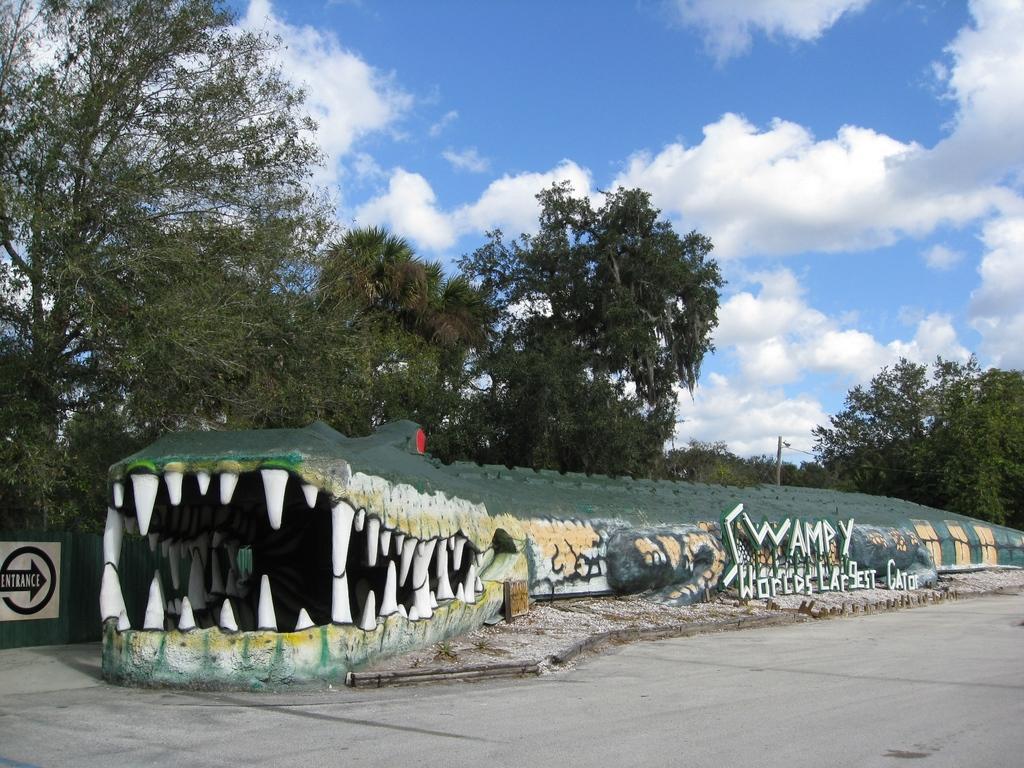In one or two sentences, can you explain what this image depicts? In the center of the image we can see one crocodile architecture. On the crocodile architecture, it is written as "Swampy World's Largest Gator". In the background, we can see the sky, clouds, trees, one sign board, one pole, road and a few other objects. 